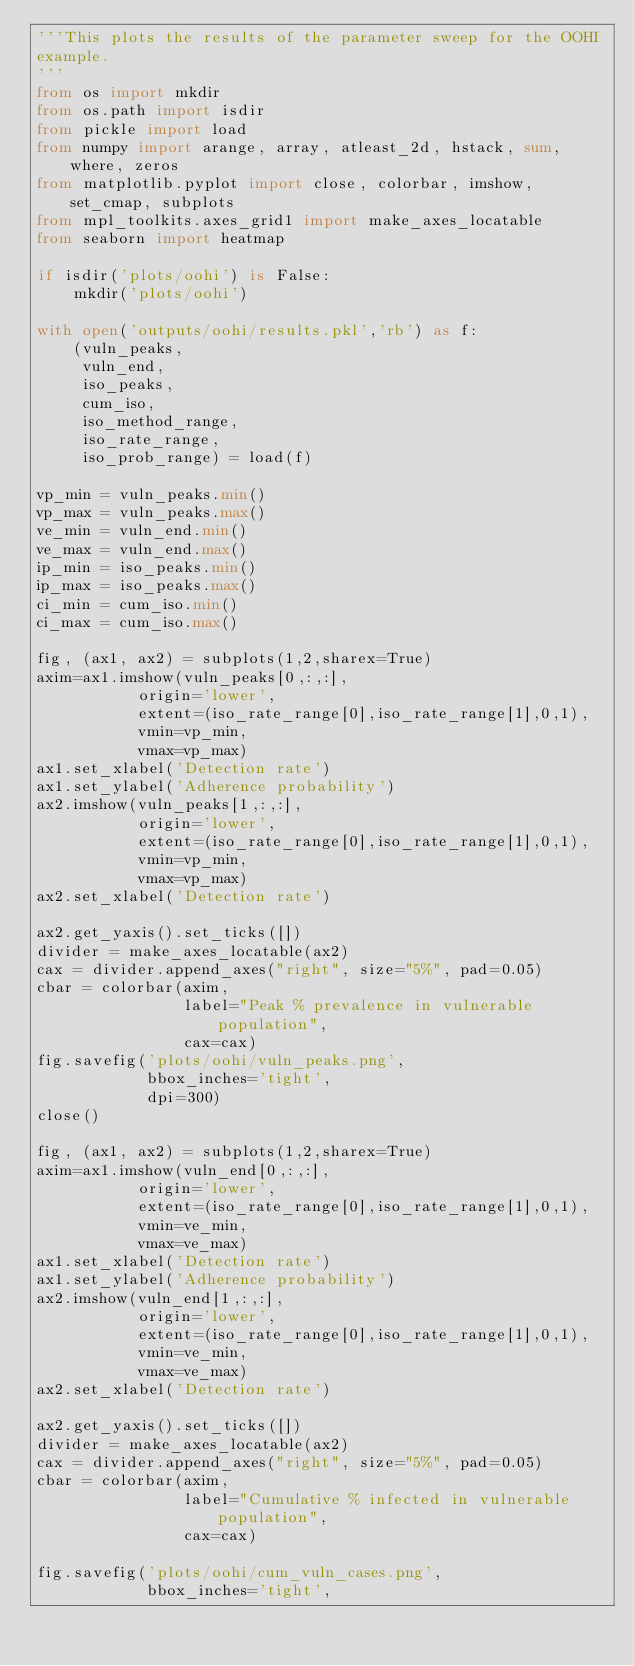<code> <loc_0><loc_0><loc_500><loc_500><_Python_>'''This plots the results of the parameter sweep for the OOHI
example.
'''
from os import mkdir
from os.path import isdir
from pickle import load
from numpy import arange, array, atleast_2d, hstack, sum, where, zeros
from matplotlib.pyplot import close, colorbar, imshow, set_cmap, subplots
from mpl_toolkits.axes_grid1 import make_axes_locatable
from seaborn import heatmap

if isdir('plots/oohi') is False:
    mkdir('plots/oohi')

with open('outputs/oohi/results.pkl','rb') as f:
    (vuln_peaks,
     vuln_end,
     iso_peaks,
     cum_iso,
     iso_method_range,
     iso_rate_range,
     iso_prob_range) = load(f)

vp_min = vuln_peaks.min()
vp_max = vuln_peaks.max()
ve_min = vuln_end.min()
ve_max = vuln_end.max()
ip_min = iso_peaks.min()
ip_max = iso_peaks.max()
ci_min = cum_iso.min()
ci_max = cum_iso.max()

fig, (ax1, ax2) = subplots(1,2,sharex=True)
axim=ax1.imshow(vuln_peaks[0,:,:],
           origin='lower',
           extent=(iso_rate_range[0],iso_rate_range[1],0,1),
           vmin=vp_min,
           vmax=vp_max)
ax1.set_xlabel('Detection rate')
ax1.set_ylabel('Adherence probability')
ax2.imshow(vuln_peaks[1,:,:],
           origin='lower',
           extent=(iso_rate_range[0],iso_rate_range[1],0,1),
           vmin=vp_min,
           vmax=vp_max)
ax2.set_xlabel('Detection rate')

ax2.get_yaxis().set_ticks([])
divider = make_axes_locatable(ax2)
cax = divider.append_axes("right", size="5%", pad=0.05)
cbar = colorbar(axim,
                label="Peak % prevalence in vulnerable population",
                cax=cax)
fig.savefig('plots/oohi/vuln_peaks.png',
            bbox_inches='tight',
            dpi=300)
close()

fig, (ax1, ax2) = subplots(1,2,sharex=True)
axim=ax1.imshow(vuln_end[0,:,:],
           origin='lower',
           extent=(iso_rate_range[0],iso_rate_range[1],0,1),
           vmin=ve_min,
           vmax=ve_max)
ax1.set_xlabel('Detection rate')
ax1.set_ylabel('Adherence probability')
ax2.imshow(vuln_end[1,:,:],
           origin='lower',
           extent=(iso_rate_range[0],iso_rate_range[1],0,1),
           vmin=ve_min,
           vmax=ve_max)
ax2.set_xlabel('Detection rate')

ax2.get_yaxis().set_ticks([])
divider = make_axes_locatable(ax2)
cax = divider.append_axes("right", size="5%", pad=0.05)
cbar = colorbar(axim,
                label="Cumulative % infected in vulnerable population",
                cax=cax)

fig.savefig('plots/oohi/cum_vuln_cases.png',
            bbox_inches='tight',</code> 